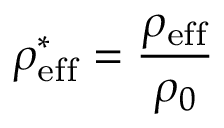Convert formula to latex. <formula><loc_0><loc_0><loc_500><loc_500>\rho _ { e f f } ^ { * } = \frac { \rho _ { e f f } } { \rho _ { 0 } }</formula> 